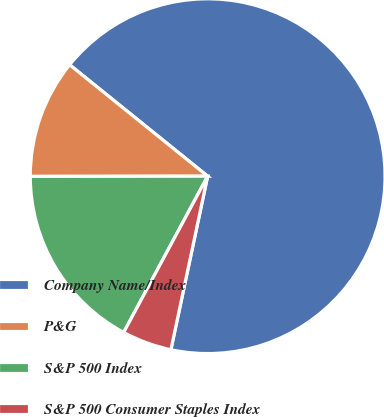Convert chart to OTSL. <chart><loc_0><loc_0><loc_500><loc_500><pie_chart><fcel>Company Name/Index<fcel>P&G<fcel>S&P 500 Index<fcel>S&P 500 Consumer Staples Index<nl><fcel>67.52%<fcel>10.83%<fcel>17.13%<fcel>4.53%<nl></chart> 